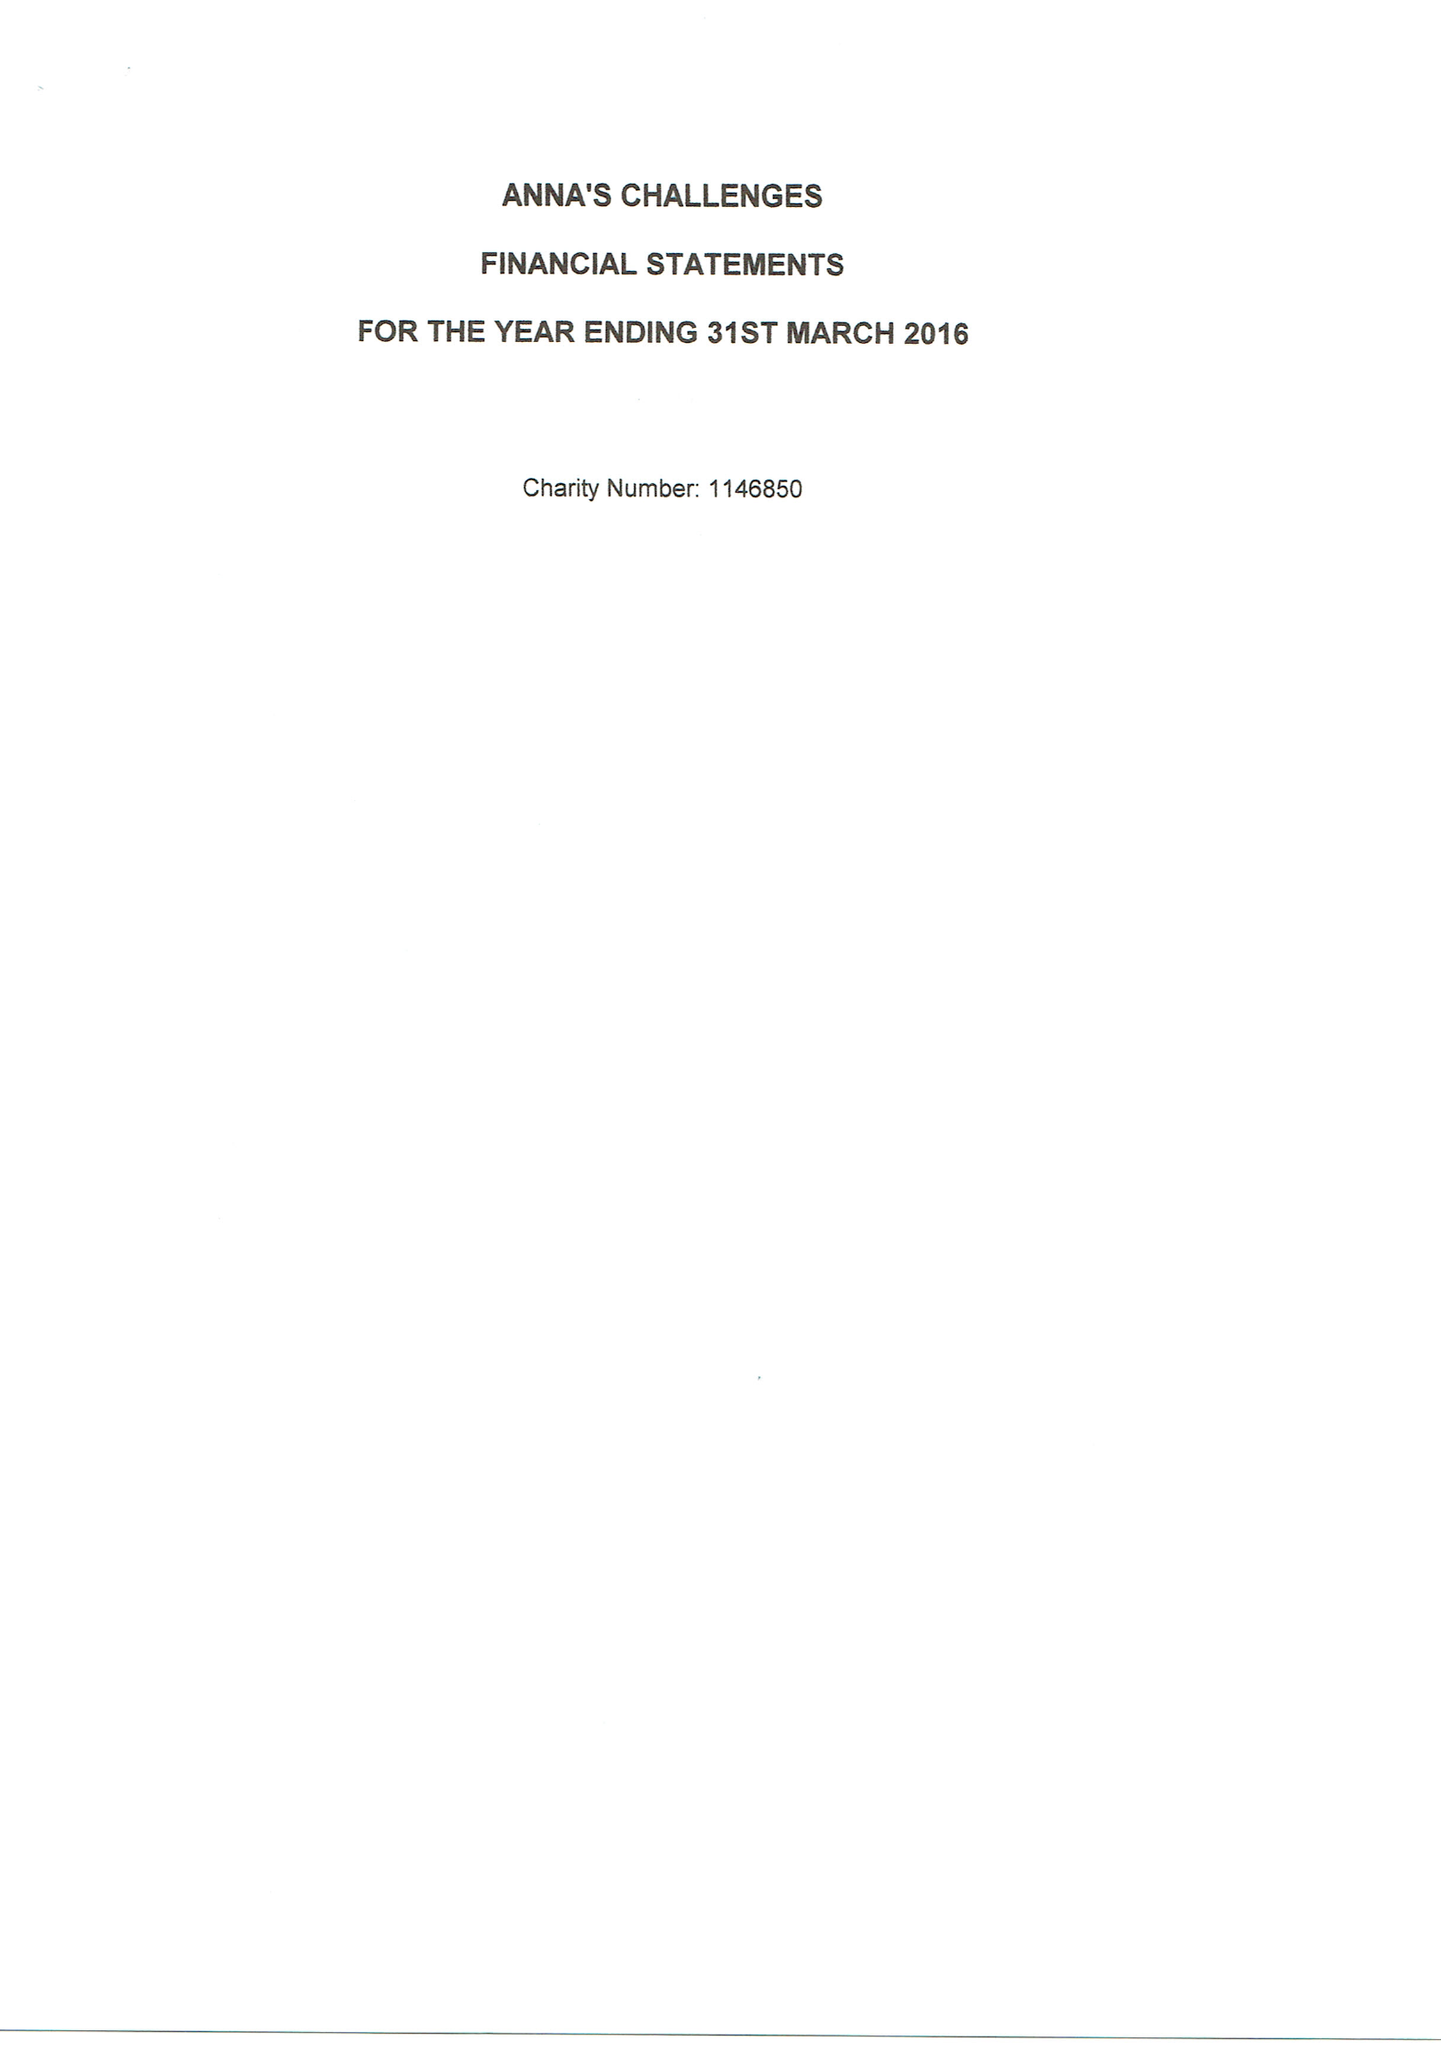What is the value for the address__post_town?
Answer the question using a single word or phrase. READING 